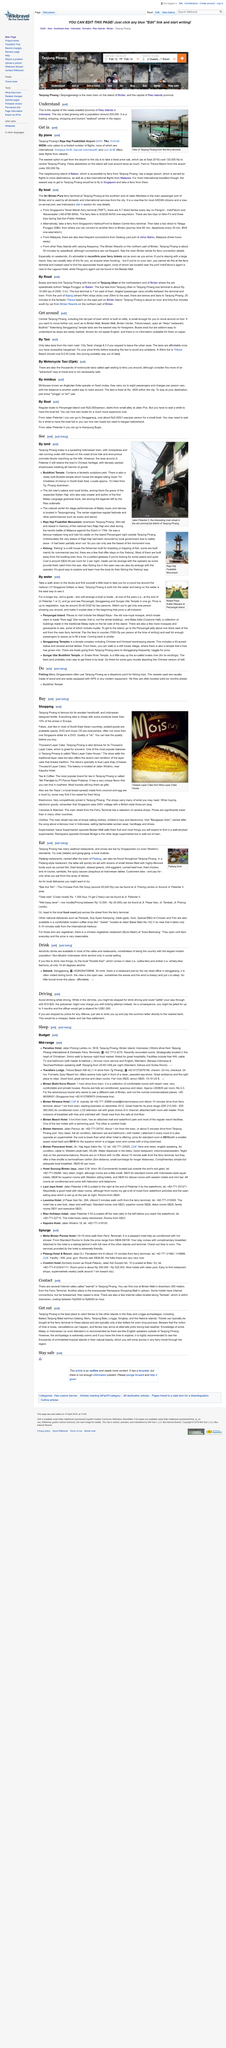List a handful of essential elements in this visual. A 40 km trip to Trikora Beach should cost approximately $0.50. The easiest way for foreigners to move further out to destinations such as Bintan Mall is by taking Temple taxis. City Taxis charge $0.3 for each request to leave the urban area. 